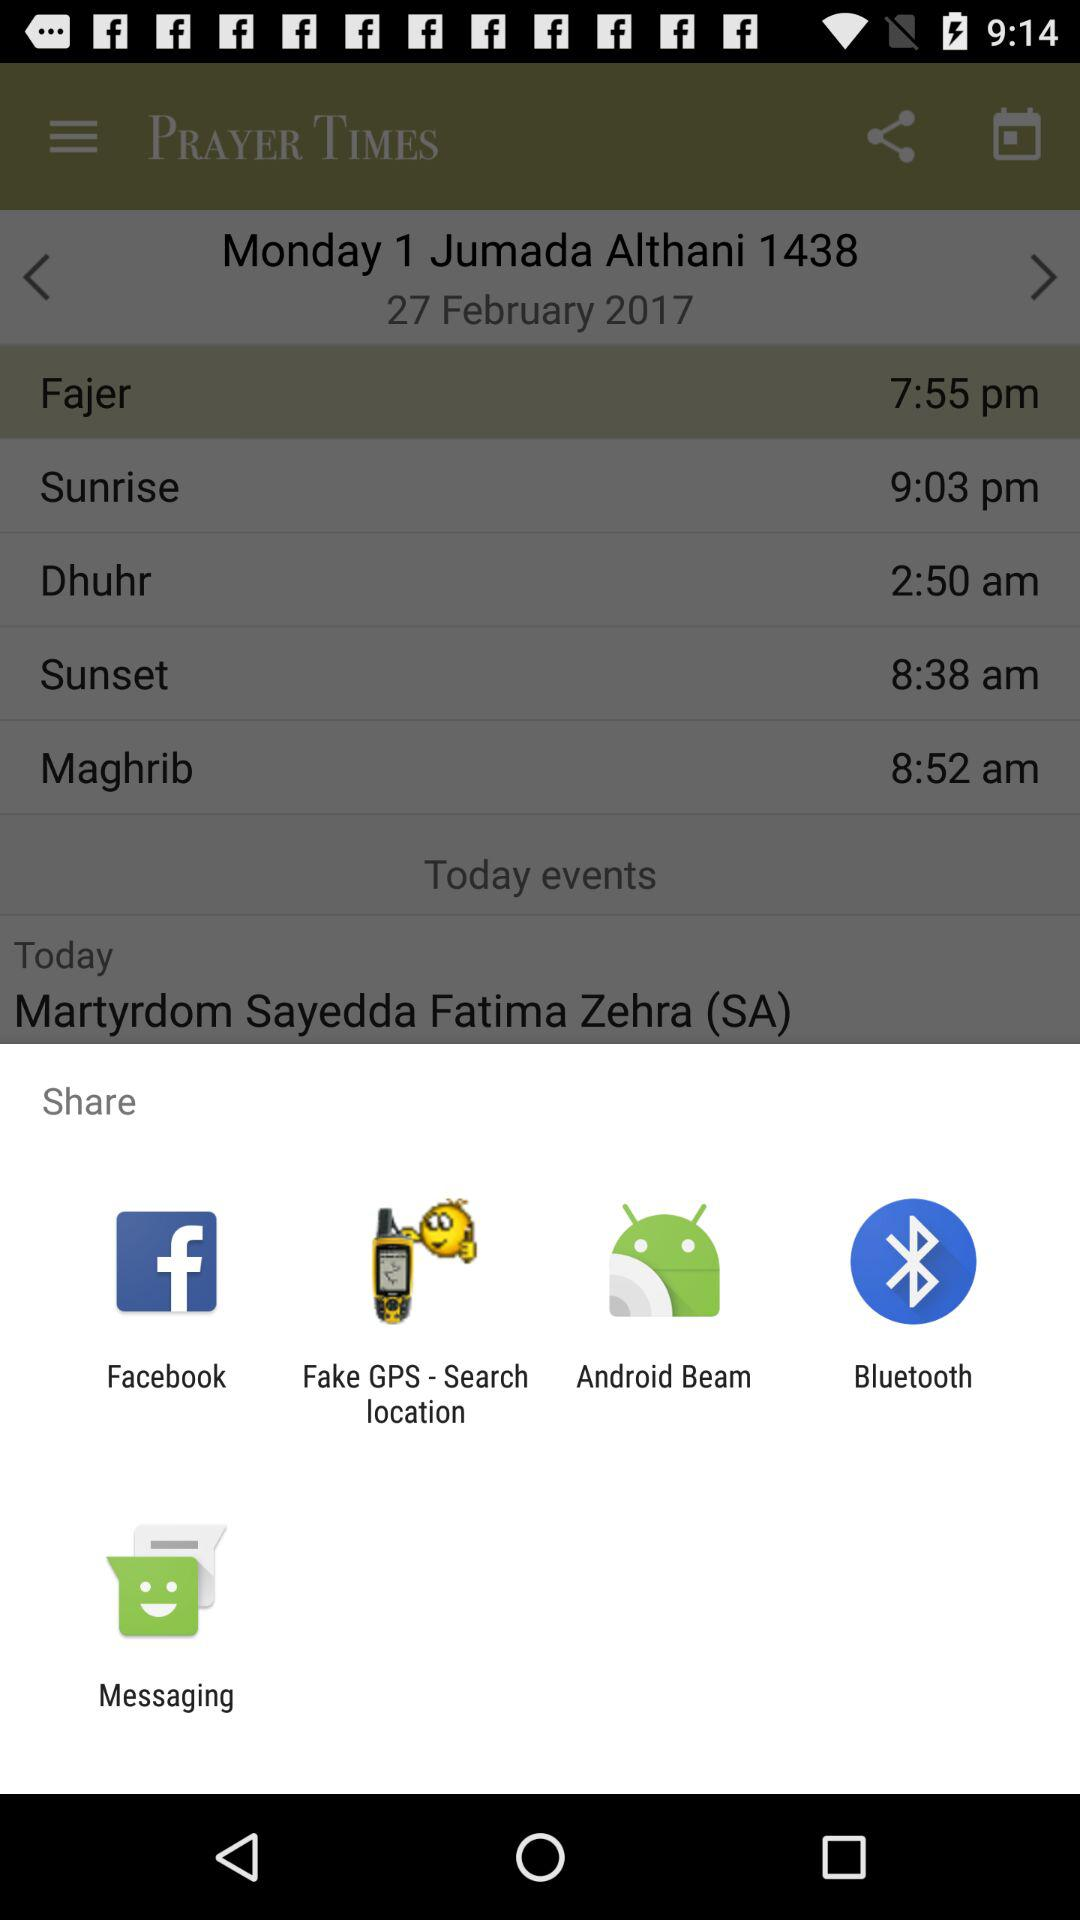At what time was the sunset prayer on January 31?
When the provided information is insufficient, respond with <no answer>. <no answer> 